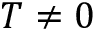<formula> <loc_0><loc_0><loc_500><loc_500>T \neq 0</formula> 